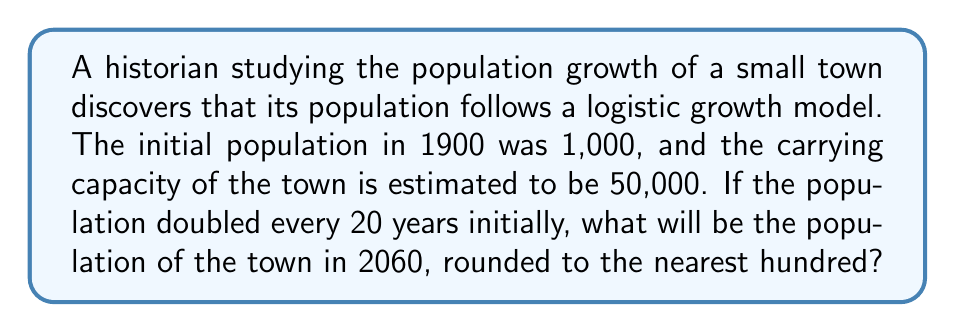Can you solve this math problem? To solve this problem, we'll use the logistic growth model and follow these steps:

1) The logistic growth model is given by:
   $$P(t) = \frac{K}{1 + (\frac{K}{P_0} - 1)e^{-rt}}$$
   where:
   $P(t)$ is the population at time $t$
   $K$ is the carrying capacity
   $P_0$ is the initial population
   $r$ is the growth rate

2) We're given:
   $K = 50,000$
   $P_0 = 1,000$
   The population doubles every 20 years initially

3) To find $r$, we use the doubling time formula:
   $$2 = e^{20r}$$
   $$\ln(2) = 20r$$
   $$r = \frac{\ln(2)}{20} \approx 0.0347$$

4) Now we can set up our logistic growth equation:
   $$P(t) = \frac{50000}{1 + (\frac{50000}{1000} - 1)e^{-0.0347t}}$$

5) We want to find $P(160)$ as 2060 is 160 years after 1900:
   $$P(160) = \frac{50000}{1 + (49)e^{-0.0347(160)}}$$

6) Calculating this:
   $$P(160) = \frac{50000}{1 + 49e^{-5.552}} \approx 49,306.78$$

7) Rounding to the nearest hundred:
   $$P(160) \approx 49,300$$
Answer: 49,300 